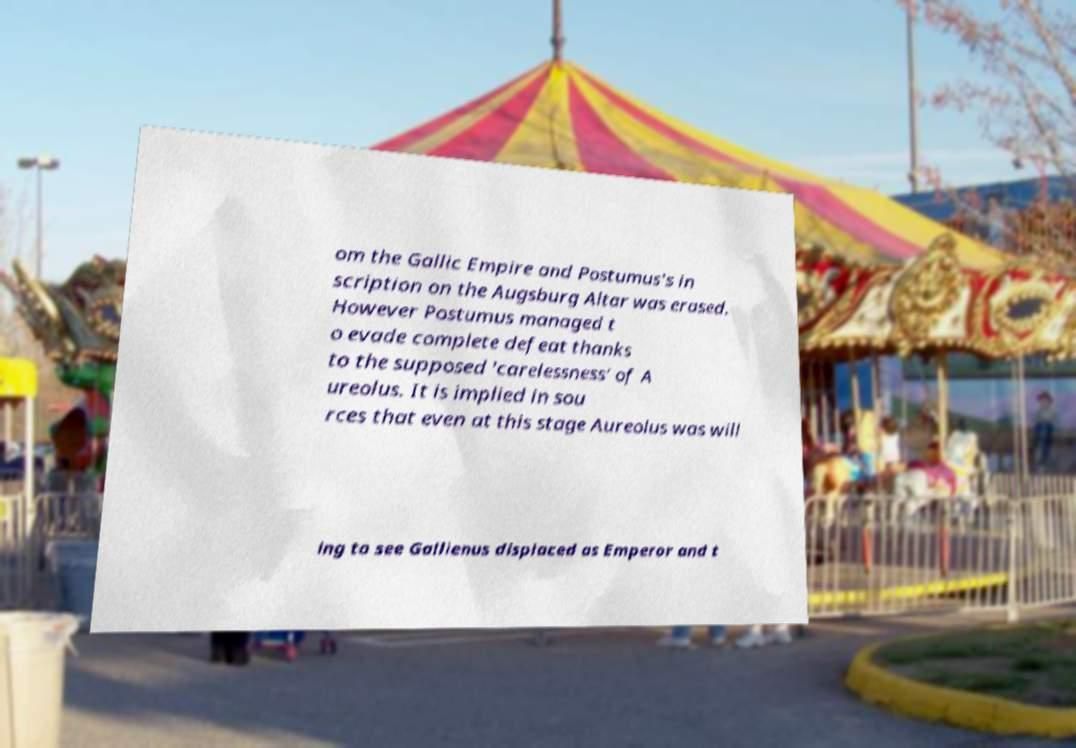Can you accurately transcribe the text from the provided image for me? om the Gallic Empire and Postumus's in scription on the Augsburg Altar was erased. However Postumus managed t o evade complete defeat thanks to the supposed 'carelessness' of A ureolus. It is implied in sou rces that even at this stage Aureolus was will ing to see Gallienus displaced as Emperor and t 